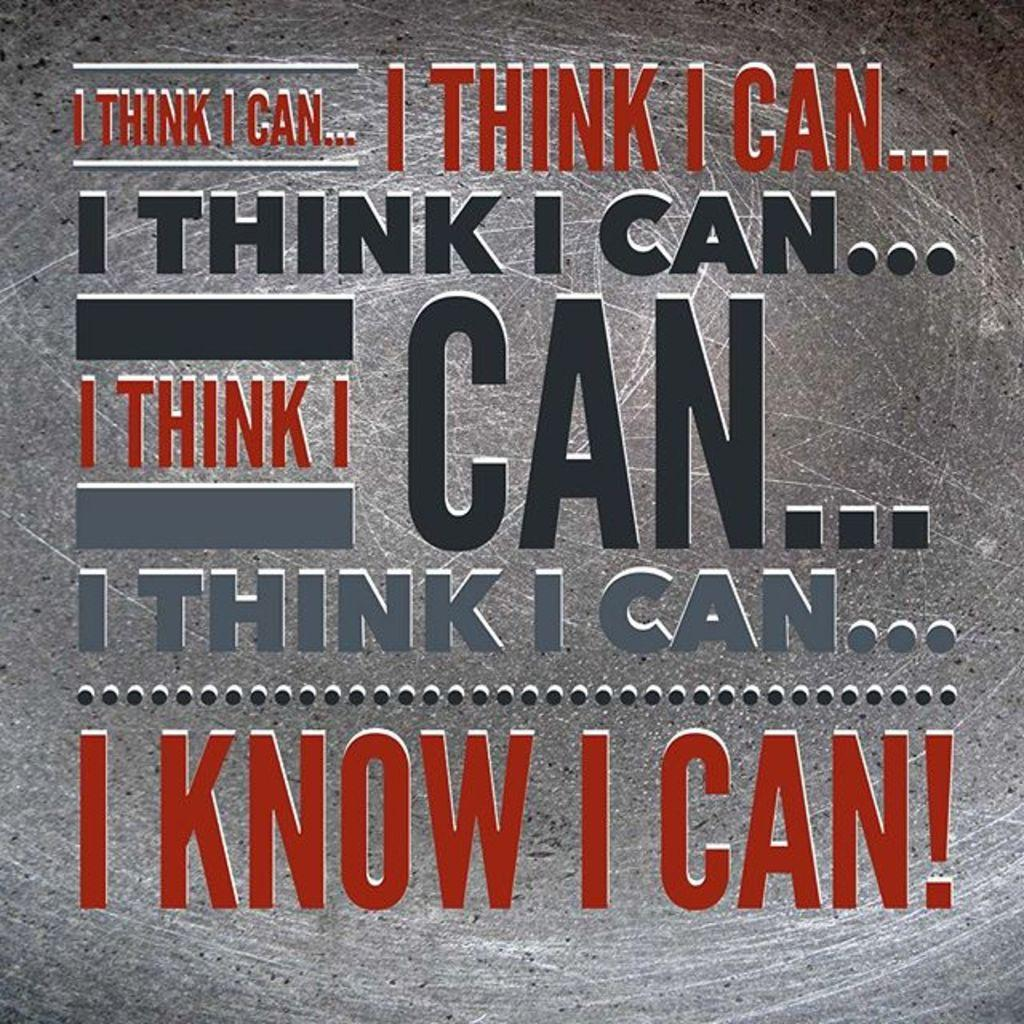Provide a one-sentence caption for the provided image. A motivational quote that state, "I know I can" is written on a gray background. 